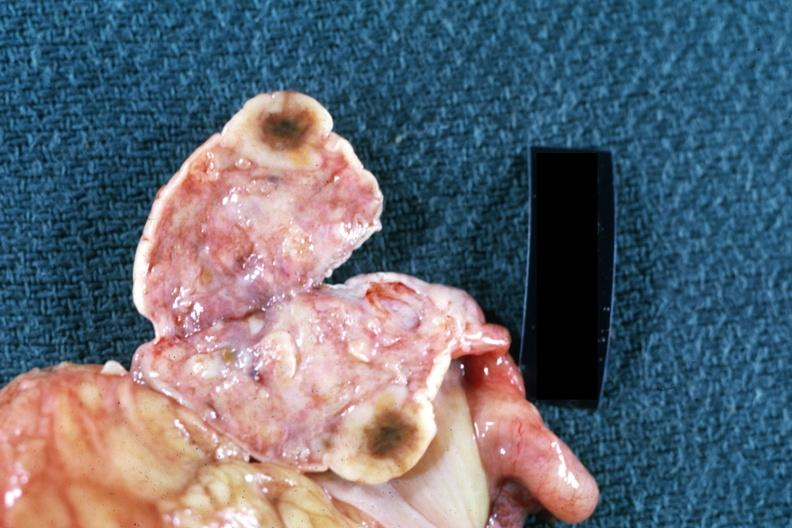s amputation stump infected present?
Answer the question using a single word or phrase. No 